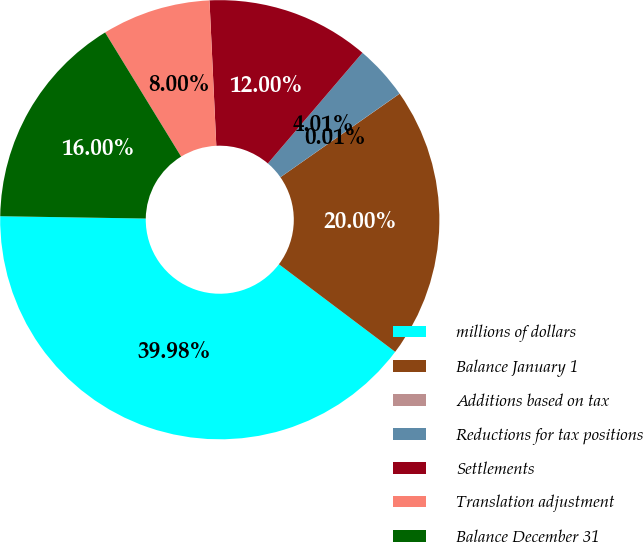Convert chart to OTSL. <chart><loc_0><loc_0><loc_500><loc_500><pie_chart><fcel>millions of dollars<fcel>Balance January 1<fcel>Additions based on tax<fcel>Reductions for tax positions<fcel>Settlements<fcel>Translation adjustment<fcel>Balance December 31<nl><fcel>39.98%<fcel>20.0%<fcel>0.01%<fcel>4.01%<fcel>12.0%<fcel>8.0%<fcel>16.0%<nl></chart> 